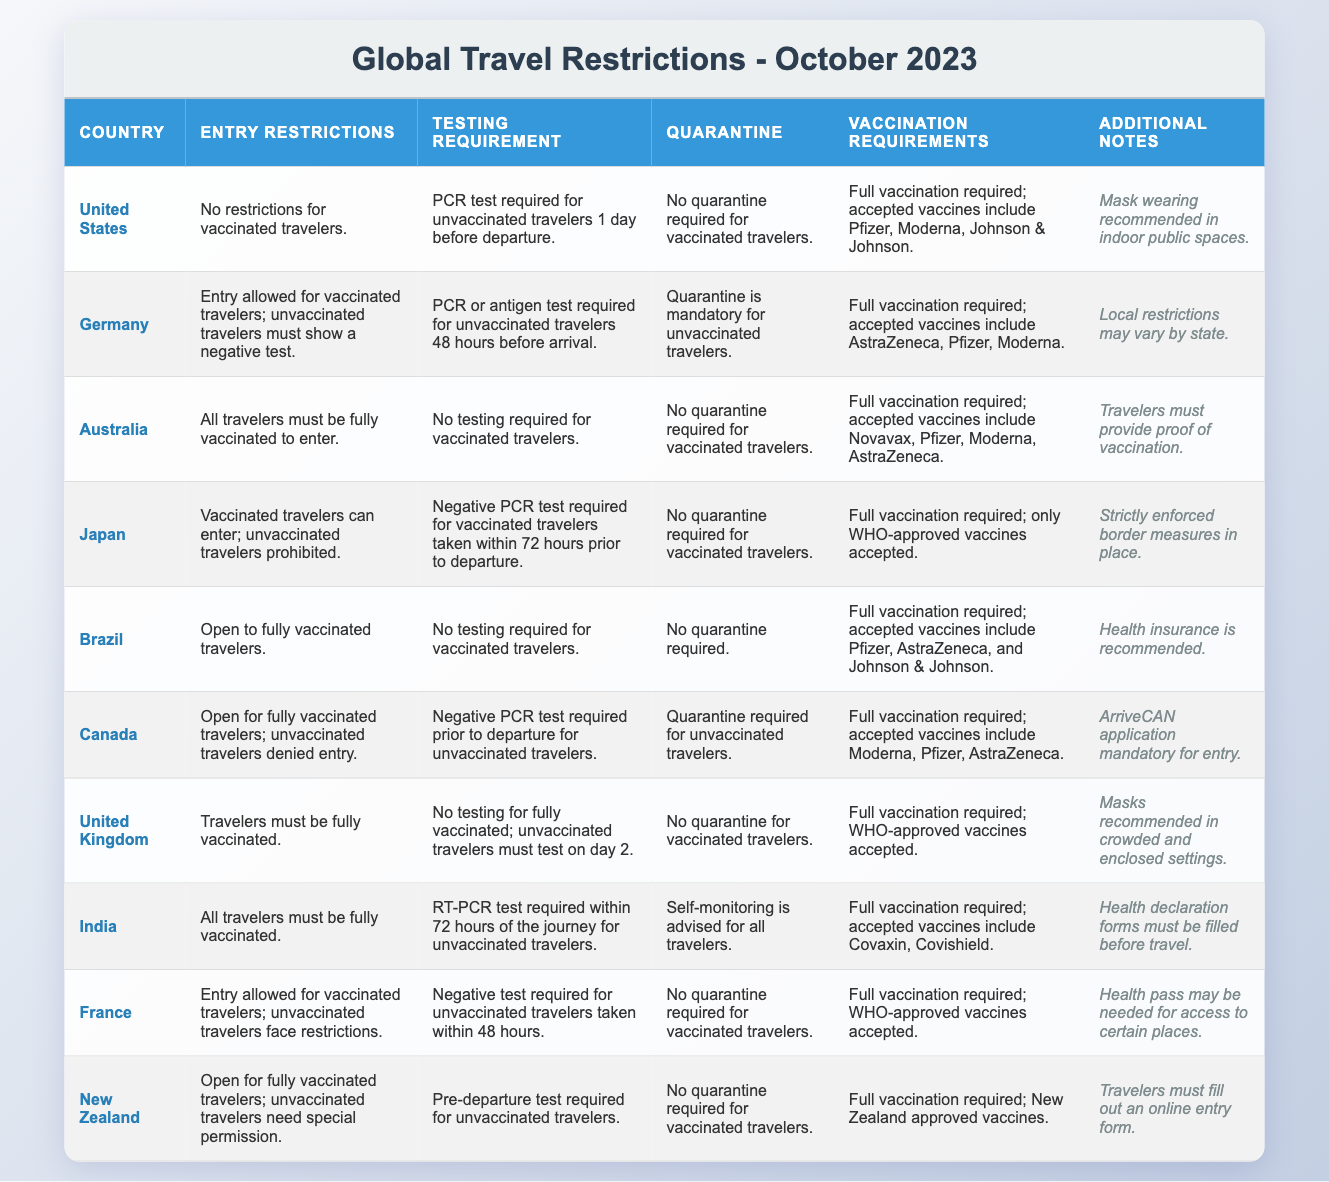What are the entry restrictions for vaccinated travelers in Australia? According to the table, Australia has entry restrictions indicating that all travelers must be fully vaccinated to enter.
Answer: All travelers must be fully vaccinated What is the testing requirement for unvaccinated travelers to Canada? The table states that unvaccinated travelers to Canada must provide a negative PCR test prior to departure.
Answer: Negative PCR test required Is quarantine mandatory for vaccinated travelers in Germany? The table specifies that quarantine is mandatory for unvaccinated travelers; thus, vaccinated travelers are not required to quarantine.
Answer: No Which countries require proof of vaccination? The countries that require proof of vaccination as per the table are Australia and New Zealand.
Answer: Australia and New Zealand What are the vaccination requirements in France? The table shows that full vaccination is required to enter France, and WHO-approved vaccines are accepted.
Answer: Full vaccination required; WHO-approved vaccines accepted Can unvaccinated travelers enter Japan? As indicated in the table, unvaccinated travelers are prohibited from entering Japan.
Answer: No, they are prohibited How many countries allow entry for fully vaccinated travelers without testing requirements? The table lists Brazil, Australia, and the United States as countries where fully vaccinated travelers can enter without testing. The tally is thus three countries: Brazil, Australia, and the United States.
Answer: Three countries Is self-monitoring advised for travelers to India? According to the table, the entry guidelines for India specify that self-monitoring is indeed advised for all travelers.
Answer: Yes What additional note is recommended in the United States? Based on the table, the additional note for the United States is that mask-wearing is recommended in indoor public spaces.
Answer: Mask-wearing recommended indoors Which accepted vaccines for entry to the United States include Moderna? The table states that for the United States, accepted vaccines include Pfizer, Moderna, and Johnson & Johnson. Since Moderna is included in this list, it meets the requirement.
Answer: Pfizer, Moderna, Johnson & Johnson 